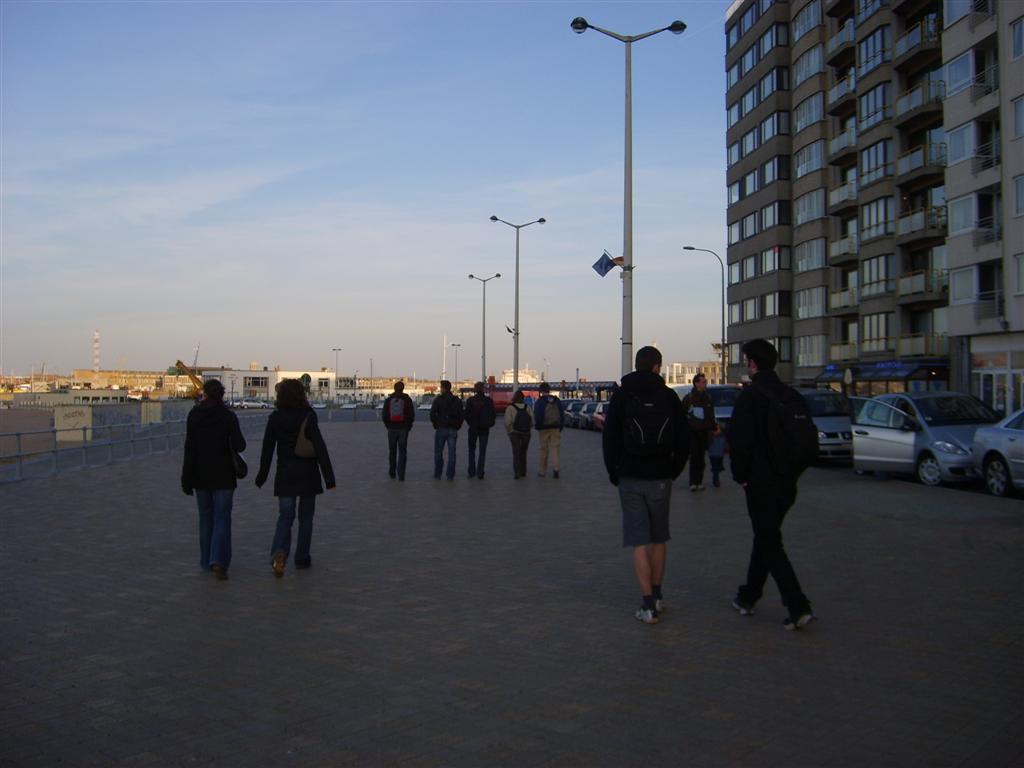Please provide a concise description of this image. In this picture we can see many people walking on the road,everyone mostly wearing black jackets. On the right side we have a building before which we have a few cars parked. we have street lights everywhere and the sky is totally bright. One side of the road is bright,sunny and the other side is totally gloomy. 